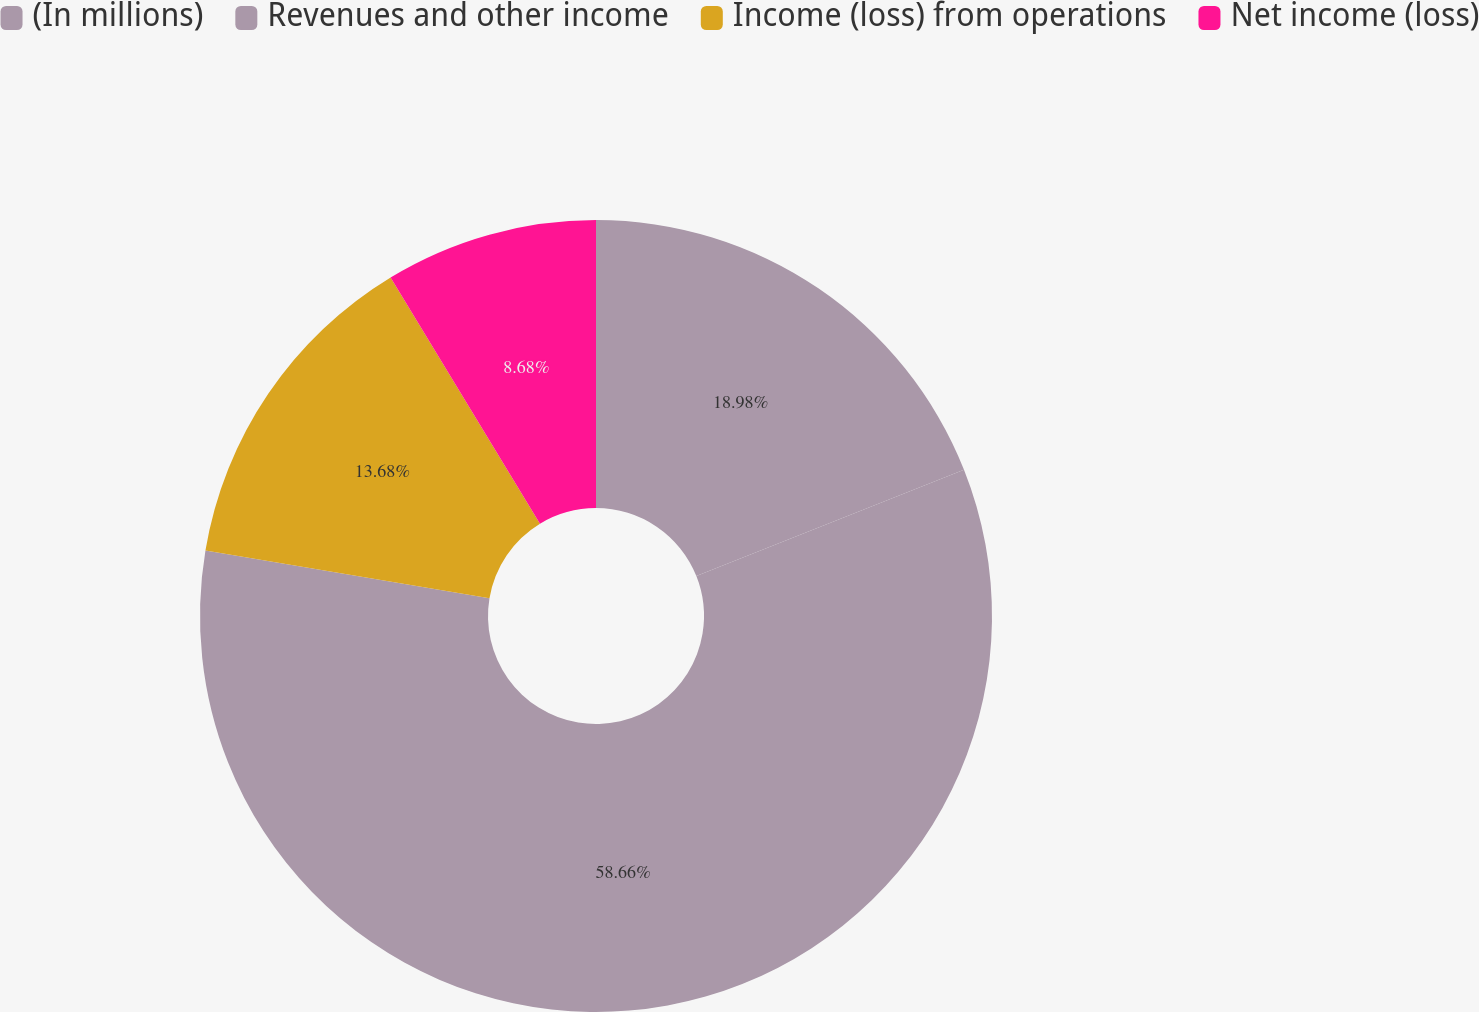Convert chart to OTSL. <chart><loc_0><loc_0><loc_500><loc_500><pie_chart><fcel>(In millions)<fcel>Revenues and other income<fcel>Income (loss) from operations<fcel>Net income (loss)<nl><fcel>18.98%<fcel>58.67%<fcel>13.68%<fcel>8.68%<nl></chart> 